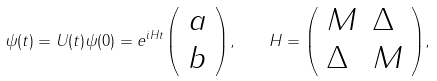<formula> <loc_0><loc_0><loc_500><loc_500>\psi ( t ) = U ( t ) \psi ( 0 ) = { e } ^ { i H t } { \left ( \begin{array} { l } { a } \\ { b } \end{array} \right ) } , \quad H = { \left ( \begin{array} { l l } { M } & { \Delta } \\ { \Delta } & { M } \end{array} \right ) } ,</formula> 